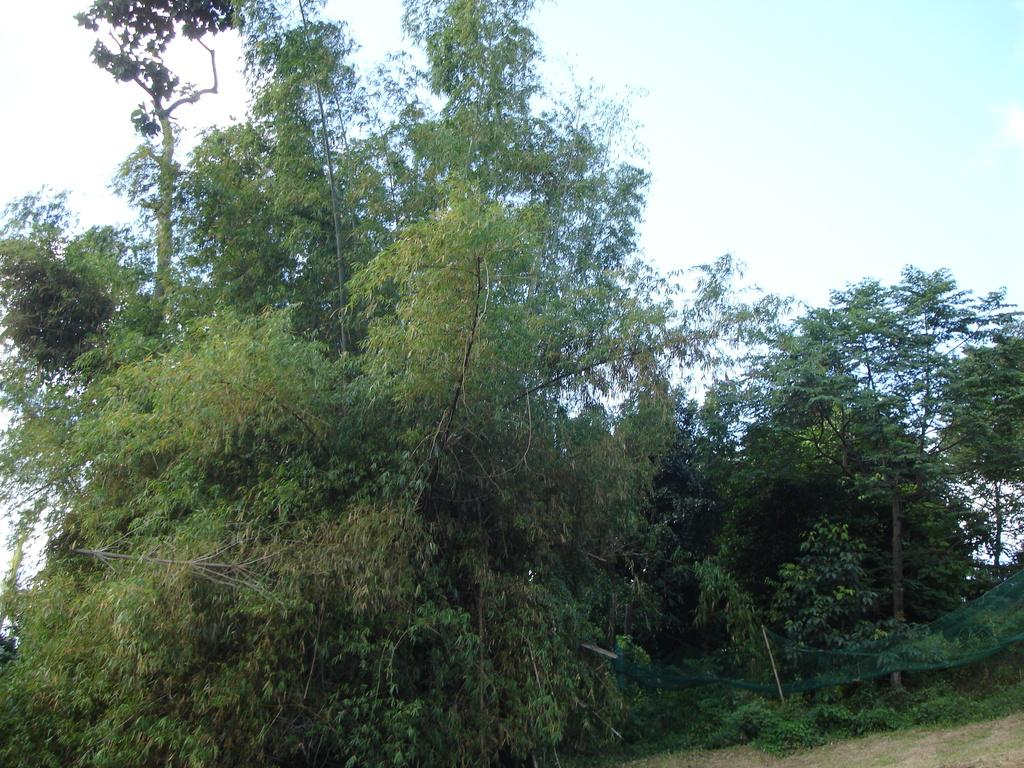What is located on the right side of the image? There is a net on the right side of the image. What can be seen in the background of the image? There are trees and the sky visible in the background of the image. What type of fruit is hanging from the net in the image? There is no fruit hanging from the net in the image. What color are the crayons used to draw the trees in the background? There are no crayons present in the image, and the trees are not drawn but are actual trees in the background. 